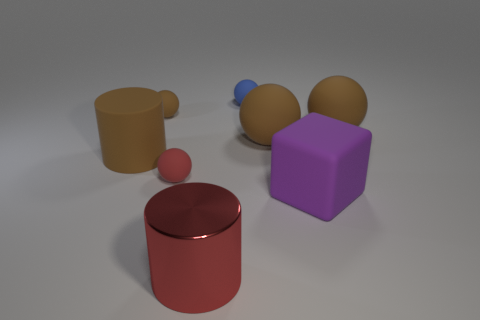How many brown spheres must be subtracted to get 1 brown spheres? 2 Subtract all yellow cylinders. How many brown balls are left? 3 Subtract all red spheres. How many spheres are left? 4 Subtract all small blue balls. How many balls are left? 4 Subtract 2 spheres. How many spheres are left? 3 Subtract all gray balls. Subtract all brown cubes. How many balls are left? 5 Add 1 purple cylinders. How many objects exist? 9 Subtract all balls. How many objects are left? 3 Add 5 brown matte cylinders. How many brown matte cylinders are left? 6 Add 2 large shiny objects. How many large shiny objects exist? 3 